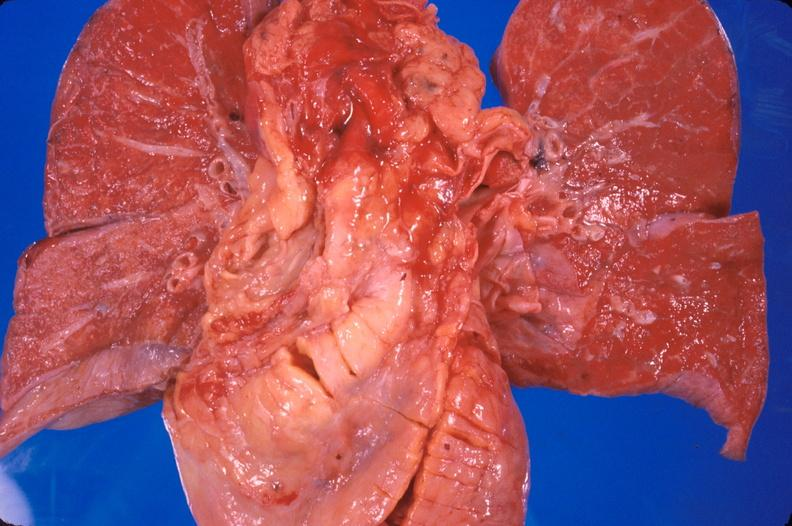does this image show heart transplant, 2 years post surgery?
Answer the question using a single word or phrase. Yes 